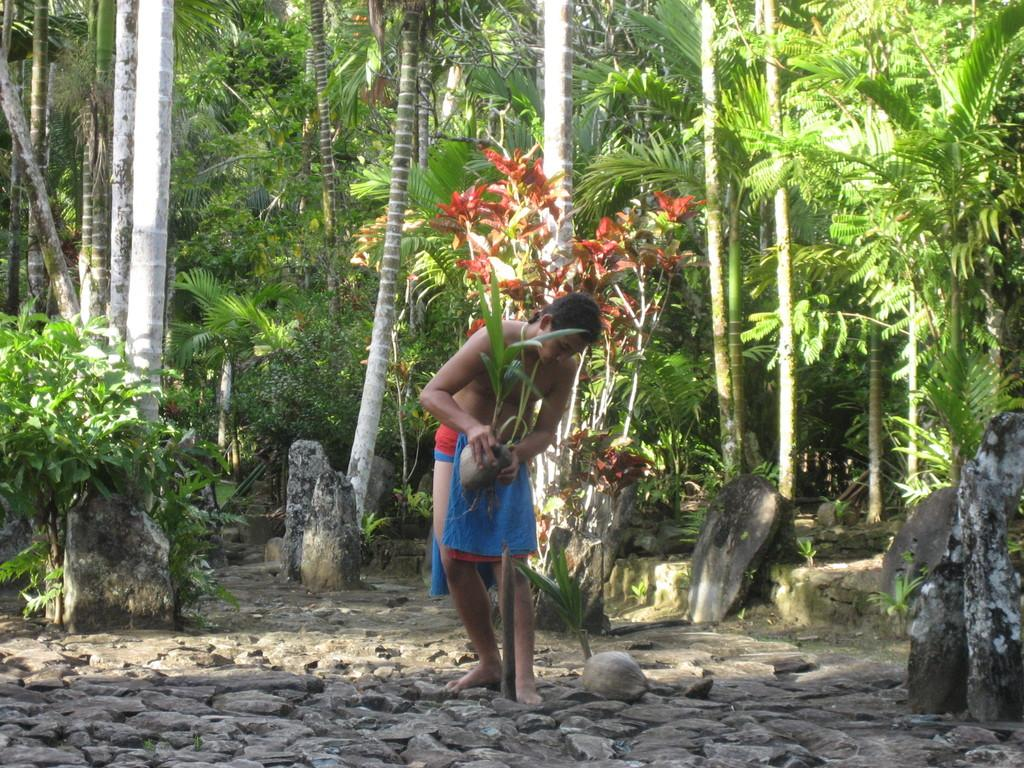What type of natural elements can be seen in the image? There are trees and plants in the image. What other objects can be seen in the image? There are stones in the image. What is the person in the image doing? The person is standing on the ground and holding a potted plant. What invention is the person sitting on in the image? There is no invention or seat visible in the image; the person is standing on the ground. Can you tell me the total cost of the items in the image based on the receipt? There is no receipt present in the image, so it is not possible to determine the cost of the items. 